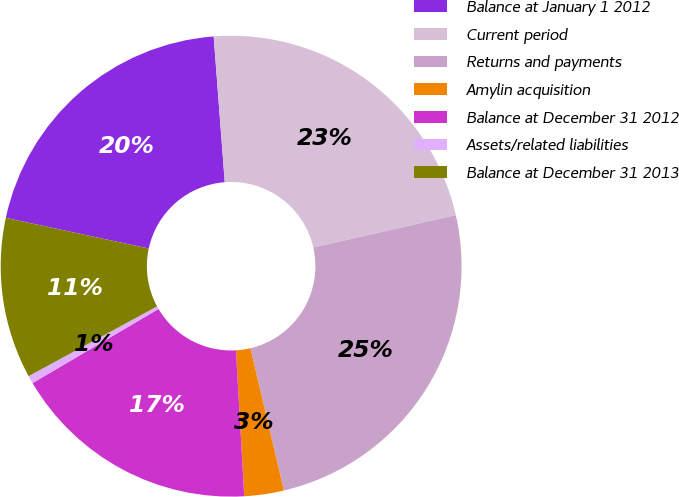Convert chart to OTSL. <chart><loc_0><loc_0><loc_500><loc_500><pie_chart><fcel>Balance at January 1 2012<fcel>Current period<fcel>Returns and payments<fcel>Amylin acquisition<fcel>Balance at December 31 2012<fcel>Assets/related liabilities<fcel>Balance at December 31 2013<nl><fcel>20.43%<fcel>22.65%<fcel>24.88%<fcel>2.77%<fcel>17.44%<fcel>0.55%<fcel>11.28%<nl></chart> 